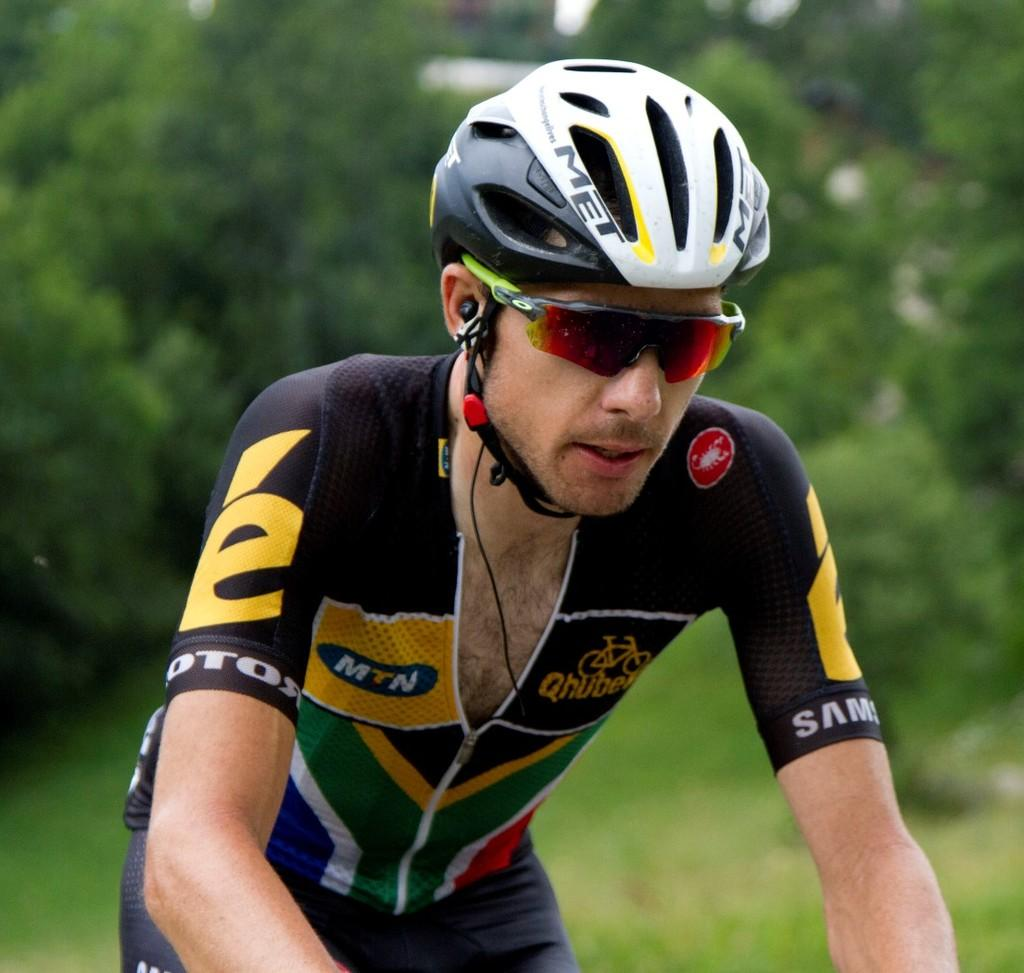Who is present in the image? There is a man in the image. What protective gear is the man wearing? The man is wearing a helmet and goggles. What can be seen in the image besides the man? There is a wire in the image. What is visible in the background of the image? There are trees in the background of the image. What advice does the doctor give to the man in the image? There is no doctor present in the image, and therefore no advice can be given. What type of cord is connected to the man's helmet in the image? There is no cord connected to the man's helmet in the image. 